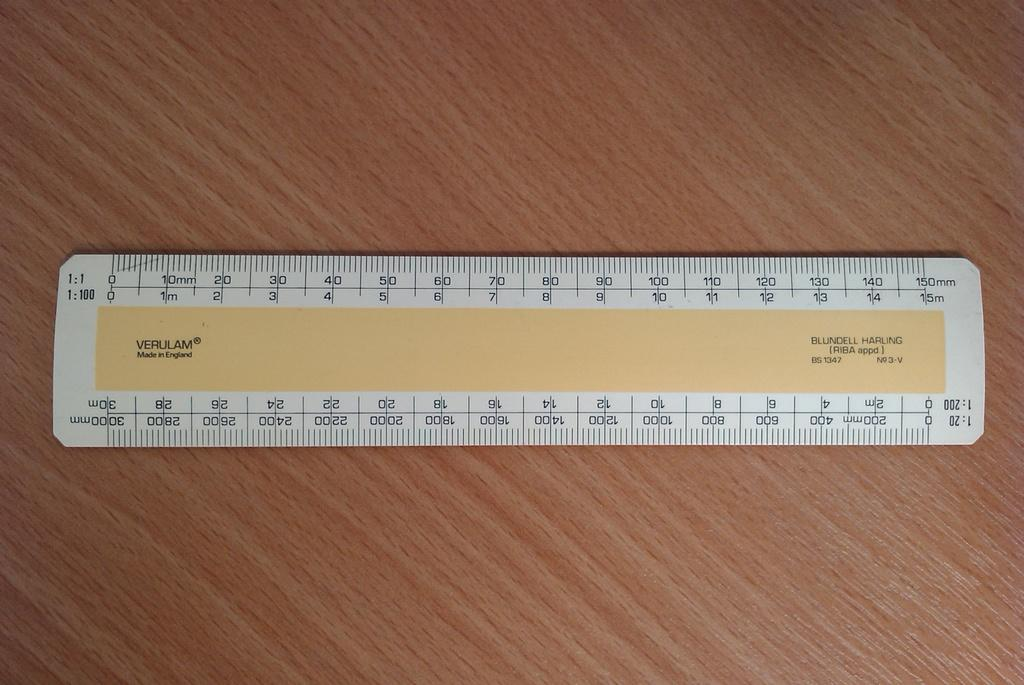<image>
Provide a brief description of the given image. A Verulam ruler, which was made in England, sits on a wood desk. 